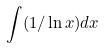Convert formula to latex. <formula><loc_0><loc_0><loc_500><loc_500>\int ( 1 / \ln x ) d x</formula> 